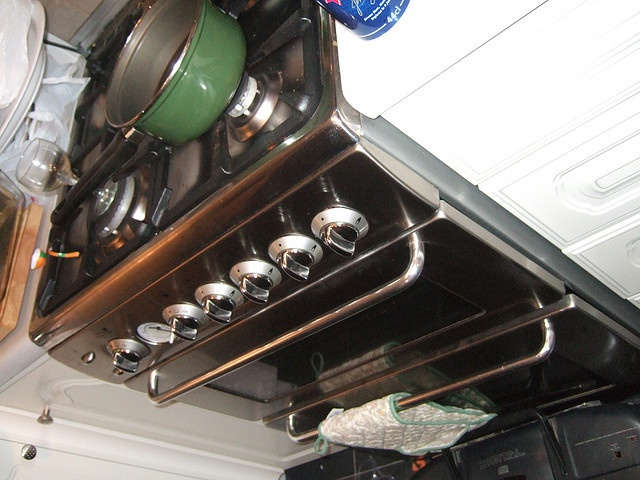Describe the objects in this image and their specific colors. I can see oven in lightgray, black, gray, and darkgray tones and wine glass in lightgray, darkgray, and gray tones in this image. 